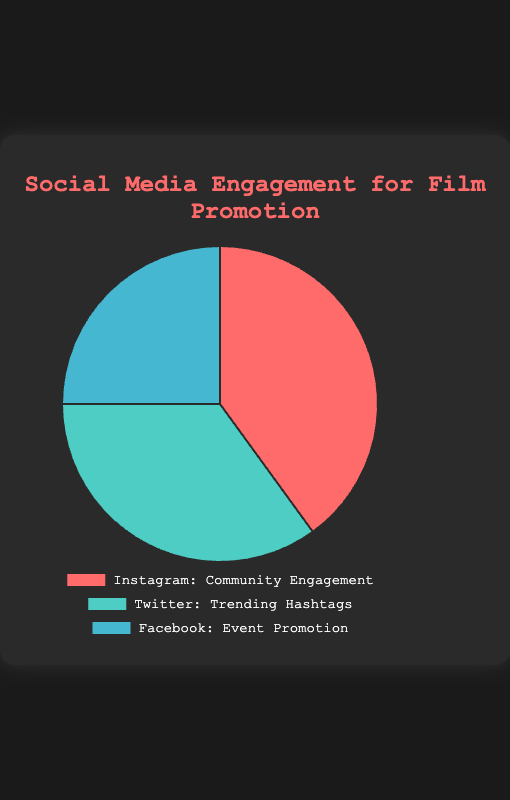Which platform has the highest percentage of engagement? The pie chart shows three platforms: Instagram, Twitter, and Facebook. Instagram has the highest percentage at 40%.
Answer: Instagram What's the combined percentage of engagement for Instagram and Twitter? According to the pie chart, Instagram has a 40% engagement rate and Twitter has a 35% engagement rate. Summing these percentages: 40% + 35% = 75%.
Answer: 75% How much more percentage does Instagram have compared to Facebook? Instagram's engagement rate is 40%, while Facebook's is 25%. The difference is 40% - 25% = 15%.
Answer: 15% What is the least engaging platform according to the pie chart? The pie chart shows Facebook, Instagram, and Twitter, with Facebook having the lowest percentage of engagement at 25%.
Answer: Facebook What category does Twitter mainly focus on? The pie chart labels Twitter as focusing on "Trending Hashtags".
Answer: Trending Hashtags Describe the color representation in the chart for each platform. Instagram is represented by a red shade, Twitter by a green shade, and Facebook by a blue shade.
Answer: Instagram: red shade, Twitter: green shade, Facebook: blue shade If Instagram's percentage was doubled, what would the new total percentage be? Doubling Instagram's percentage: 40% * 2 = 80%. Adding the percentages of Twitter and Facebook: 35% + 25% gives a total of 60%. So, 80% + 60% = 140%.
Answer: 140% Which two platforms combined make up more than half of the engagement? Summing up any two platforms to check if they exceed 50%: Instagram (40%) + Twitter (35%) = 75%, Instagram (40%) + Facebook (25%) = 65%, Twitter (35%) + Facebook (25%) = 60%. In all cases, the sum exceeds 50%.
Answer: All pairs What is the difference between the second highest and the lowest percentage? The second highest percentage is Twitter with 35%, and the lowest is Facebook with 25%. The difference is 35% - 25% = 10%.
Answer: 10% If we remove Facebook's percentage, what percentage of engagement would Instagram account for? Without Facebook, the total percentage for Instagram and Twitter is 40% + 35% = 75%. Instagram's share of the new total is (40/75) * 100 = 53.33%.
Answer: 53.33% 